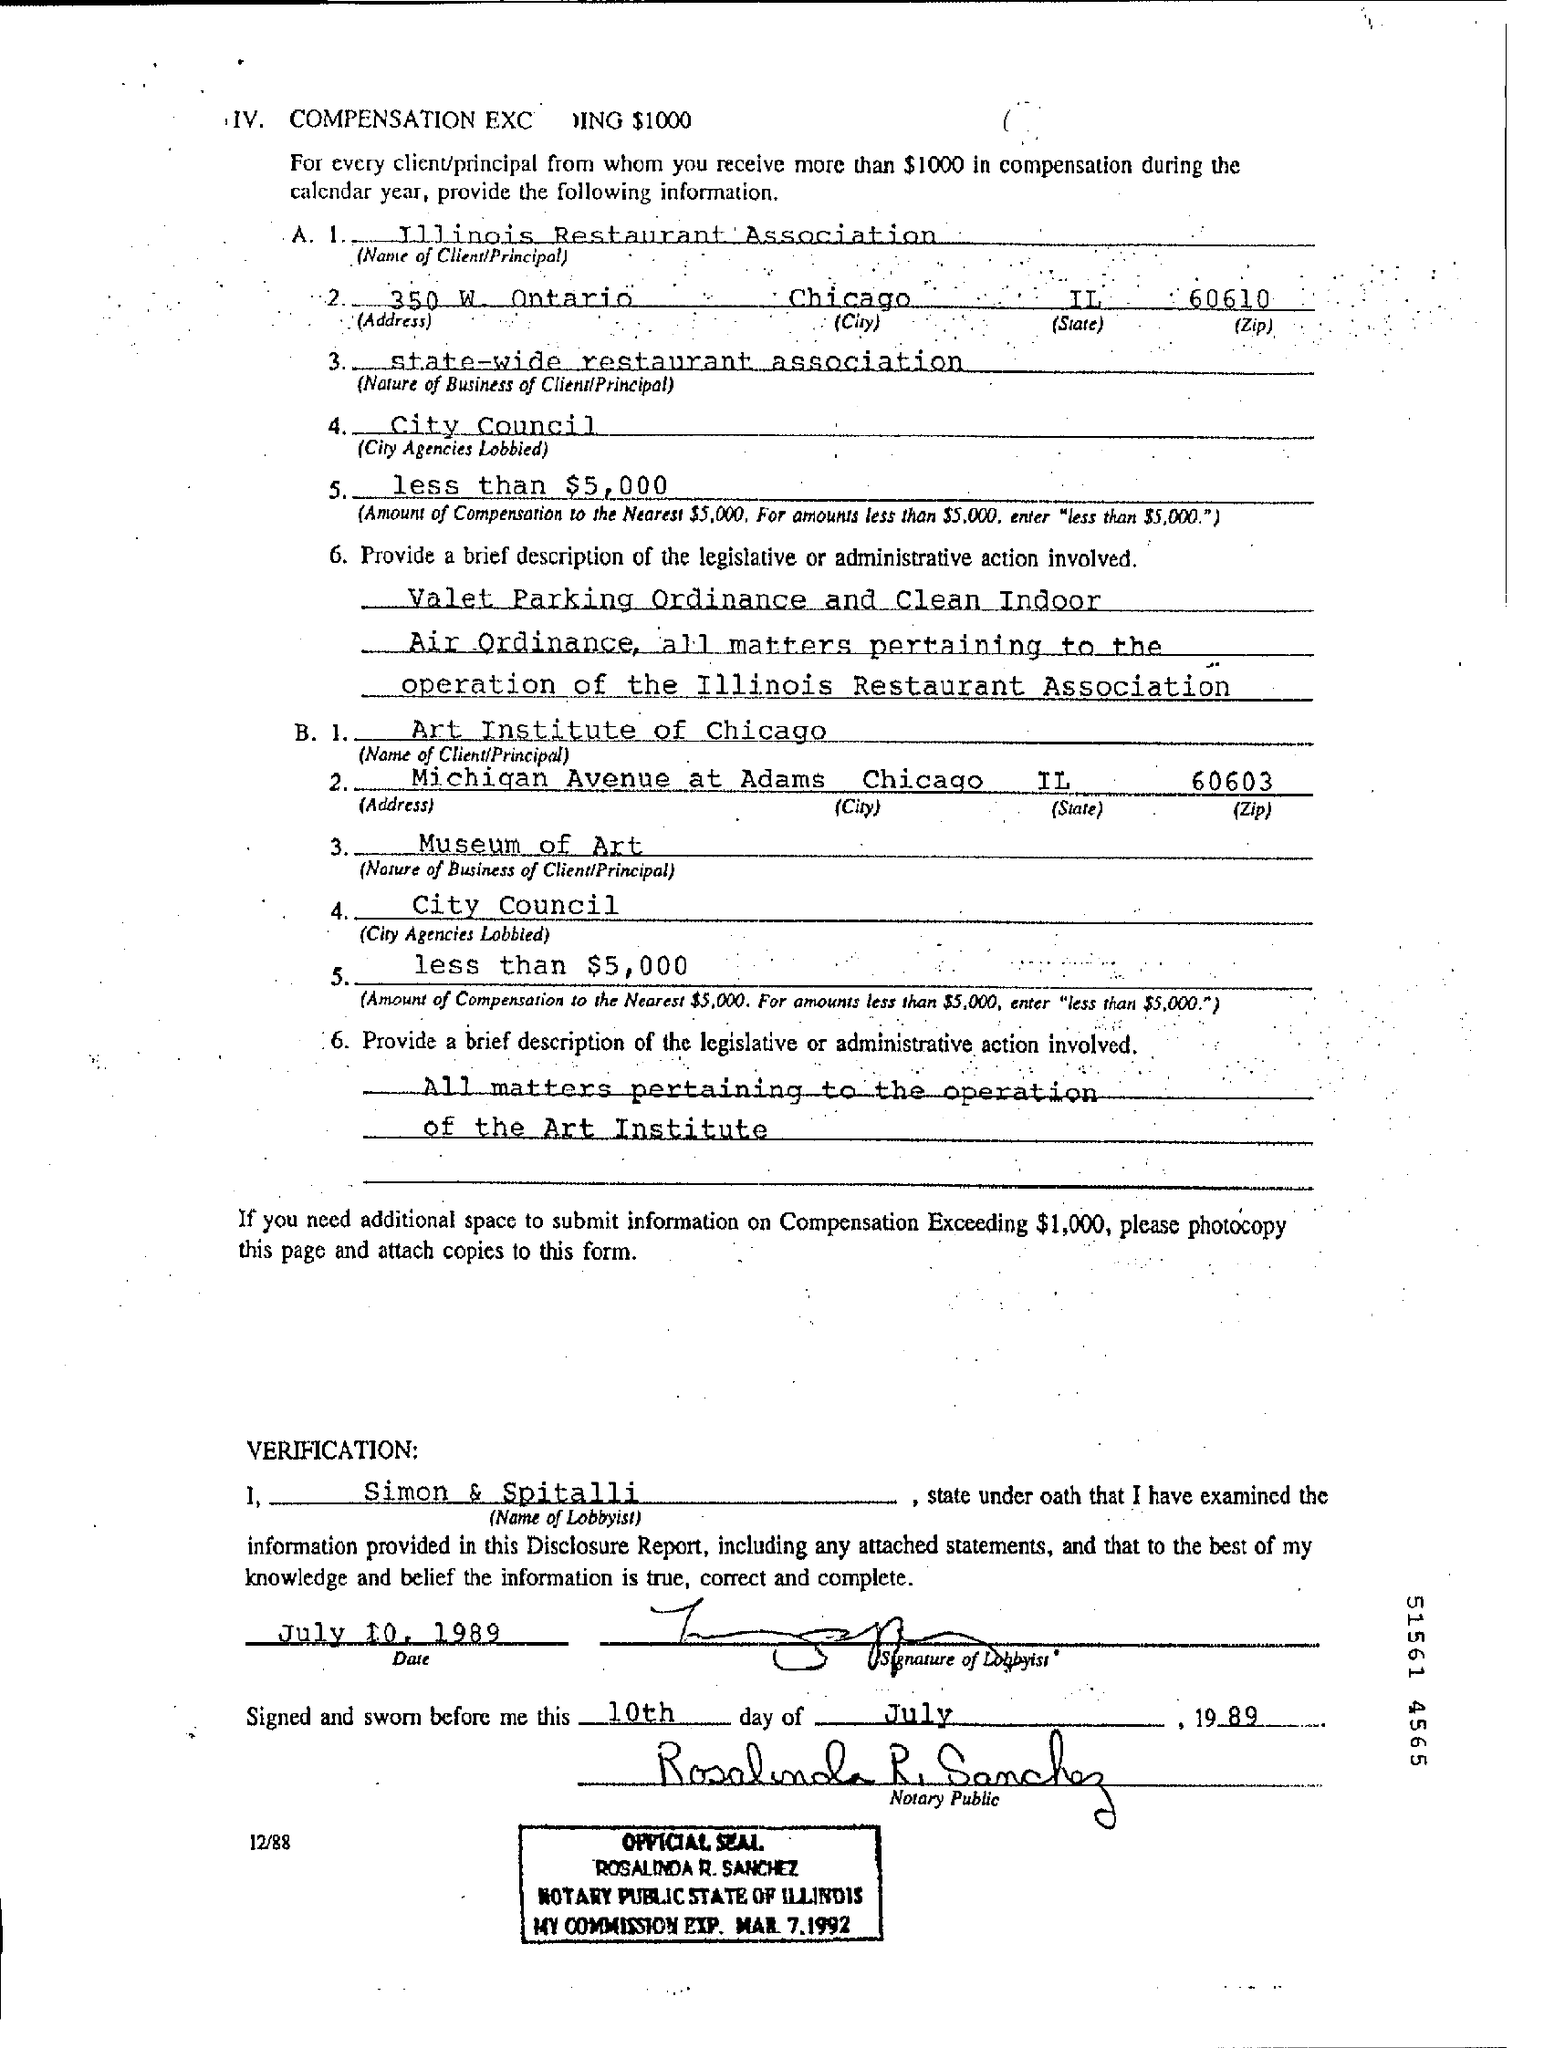What is date of verification?
Give a very brief answer. July 10, 1989. 